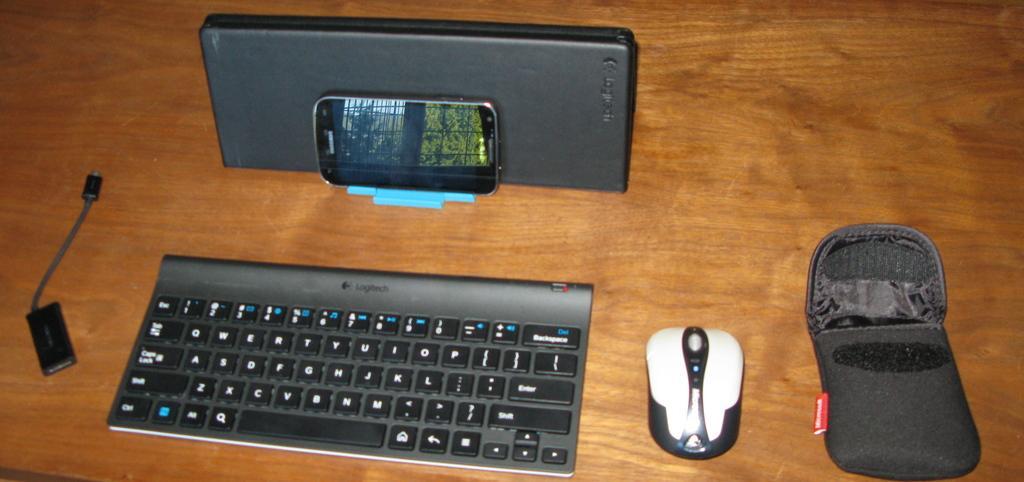Describe this image in one or two sentences. In this image I can see a keyboard, mouse, phone, USB cable and a small pouch. 